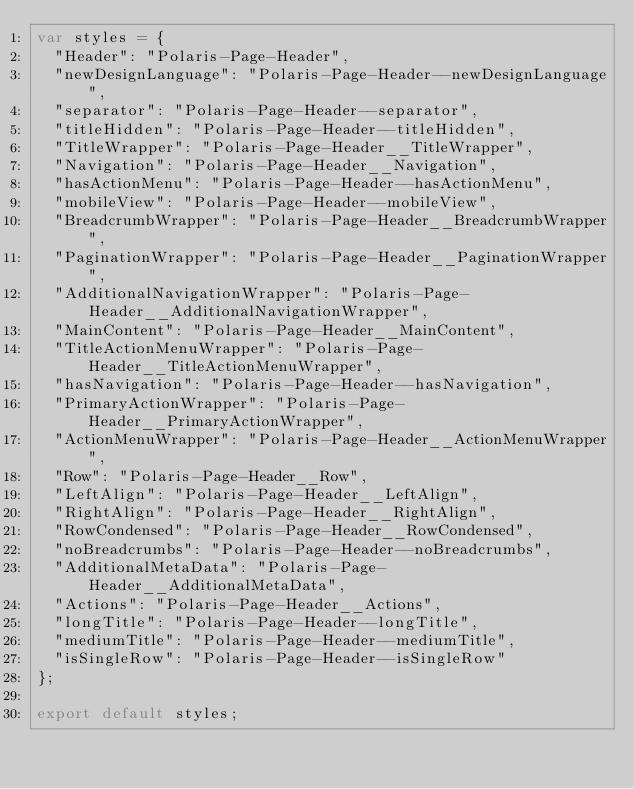Convert code to text. <code><loc_0><loc_0><loc_500><loc_500><_JavaScript_>var styles = {
  "Header": "Polaris-Page-Header",
  "newDesignLanguage": "Polaris-Page-Header--newDesignLanguage",
  "separator": "Polaris-Page-Header--separator",
  "titleHidden": "Polaris-Page-Header--titleHidden",
  "TitleWrapper": "Polaris-Page-Header__TitleWrapper",
  "Navigation": "Polaris-Page-Header__Navigation",
  "hasActionMenu": "Polaris-Page-Header--hasActionMenu",
  "mobileView": "Polaris-Page-Header--mobileView",
  "BreadcrumbWrapper": "Polaris-Page-Header__BreadcrumbWrapper",
  "PaginationWrapper": "Polaris-Page-Header__PaginationWrapper",
  "AdditionalNavigationWrapper": "Polaris-Page-Header__AdditionalNavigationWrapper",
  "MainContent": "Polaris-Page-Header__MainContent",
  "TitleActionMenuWrapper": "Polaris-Page-Header__TitleActionMenuWrapper",
  "hasNavigation": "Polaris-Page-Header--hasNavigation",
  "PrimaryActionWrapper": "Polaris-Page-Header__PrimaryActionWrapper",
  "ActionMenuWrapper": "Polaris-Page-Header__ActionMenuWrapper",
  "Row": "Polaris-Page-Header__Row",
  "LeftAlign": "Polaris-Page-Header__LeftAlign",
  "RightAlign": "Polaris-Page-Header__RightAlign",
  "RowCondensed": "Polaris-Page-Header__RowCondensed",
  "noBreadcrumbs": "Polaris-Page-Header--noBreadcrumbs",
  "AdditionalMetaData": "Polaris-Page-Header__AdditionalMetaData",
  "Actions": "Polaris-Page-Header__Actions",
  "longTitle": "Polaris-Page-Header--longTitle",
  "mediumTitle": "Polaris-Page-Header--mediumTitle",
  "isSingleRow": "Polaris-Page-Header--isSingleRow"
};

export default styles;
</code> 